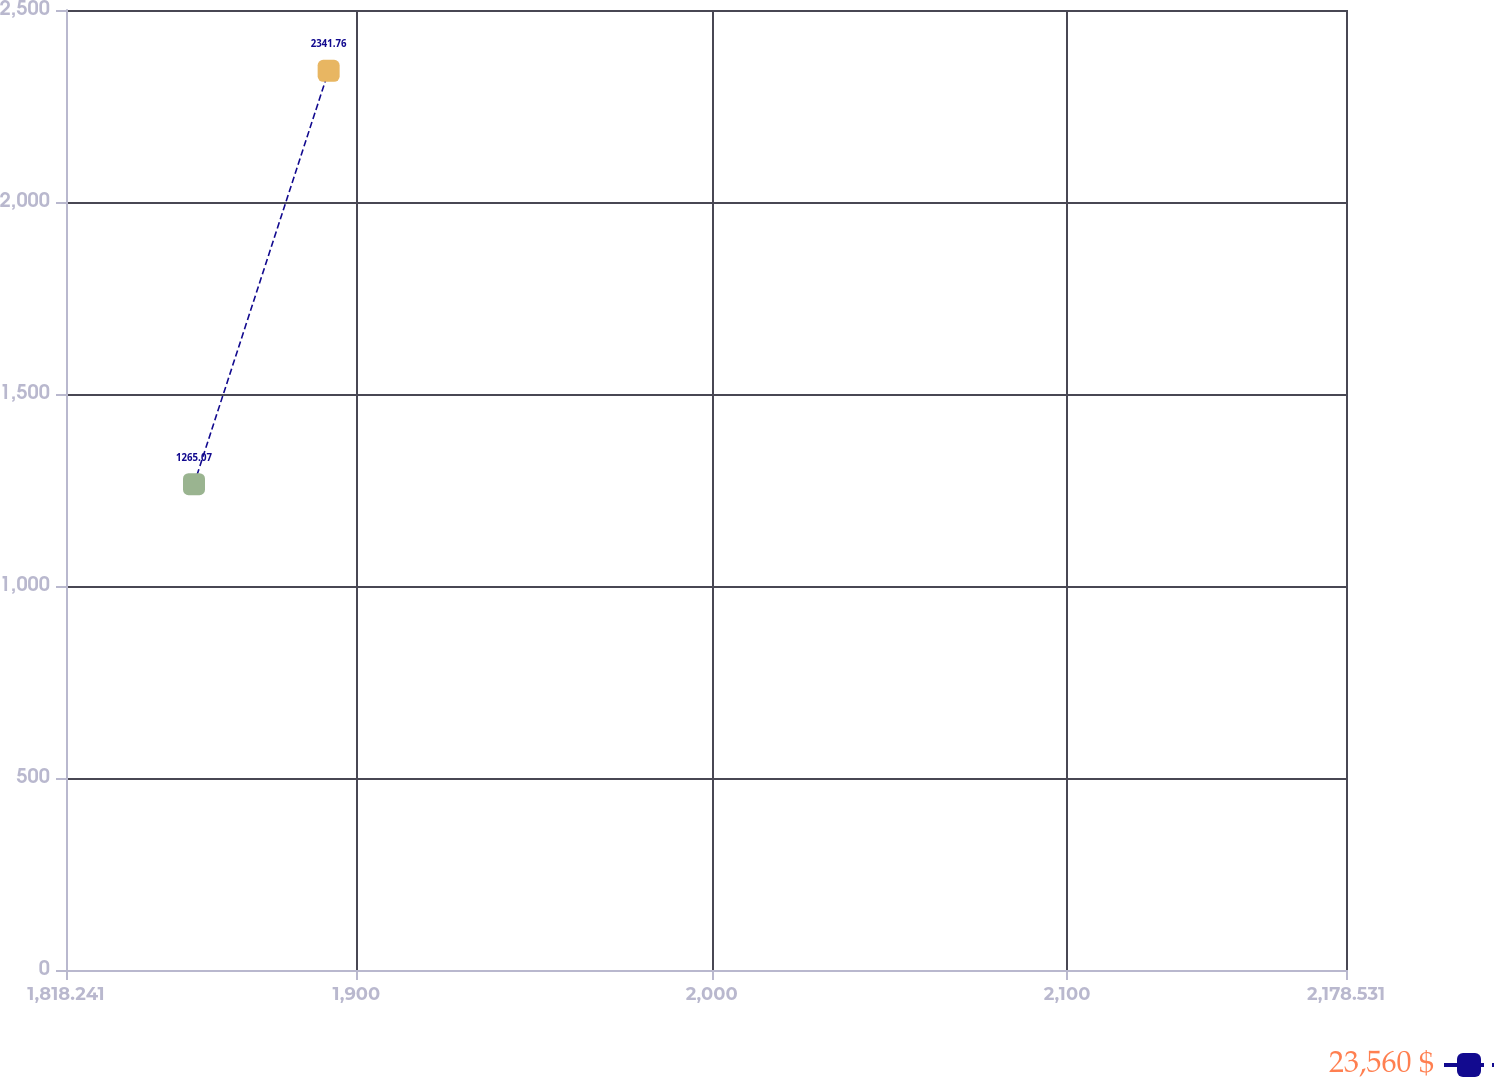Convert chart to OTSL. <chart><loc_0><loc_0><loc_500><loc_500><line_chart><ecel><fcel>23,560 $<nl><fcel>1854.27<fcel>1265.07<nl><fcel>1892.17<fcel>2341.76<nl><fcel>2179.08<fcel>475.14<nl><fcel>2214.56<fcel>3760.3<nl></chart> 